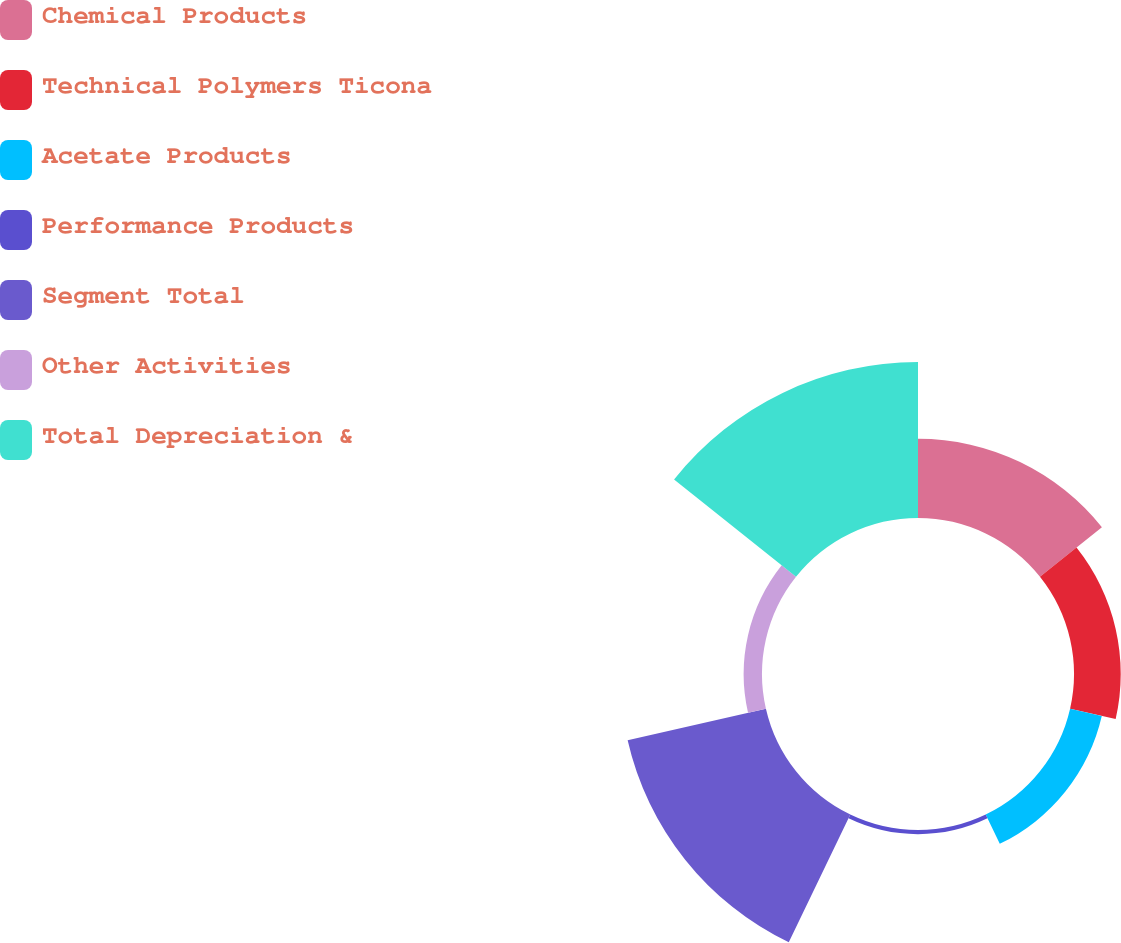<chart> <loc_0><loc_0><loc_500><loc_500><pie_chart><fcel>Chemical Products<fcel>Technical Polymers Ticona<fcel>Acetate Products<fcel>Performance Products<fcel>Segment Total<fcel>Other Activities<fcel>Total Depreciation &<nl><fcel>16.55%<fcel>9.76%<fcel>6.79%<fcel>0.87%<fcel>29.62%<fcel>3.83%<fcel>32.58%<nl></chart> 